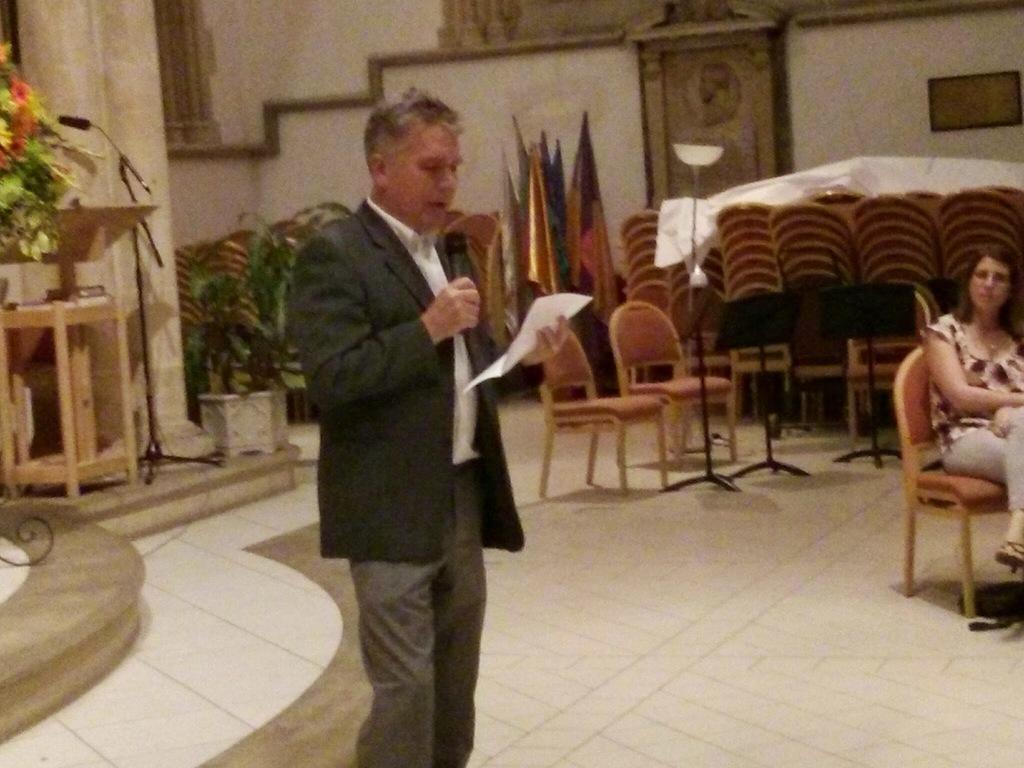Could you give a brief overview of what you see in this image? In this image the man is holding a mic and a paper and the woman is sitting on the chair. 